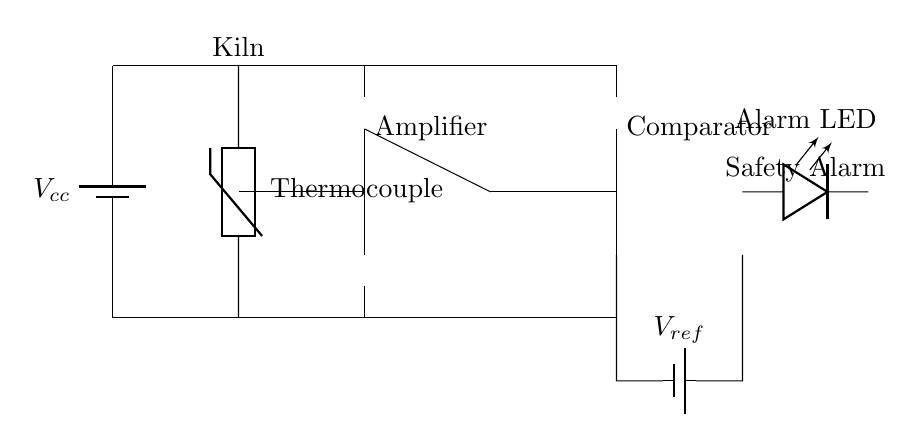What type of thermocouple is used? The circuit diagram specifies a thermistor labeled "Thermocouple," which indicates that a thermistor is employed for temperature sensing.
Answer: Thermistor What is the reference voltage labeled as? The reference voltage in the diagram is marked as "V ref," which signifies the reference point for comparison in the circuit.
Answer: V ref How many op-amps are present in the circuit? The diagram contains two op-amps, one functioning as an amplifier and the other as a comparator, which are essential for signal processing.
Answer: Two What does the alarm LED indicate? The LED labeled "Alarm LED" serves as an indicator, showing whether the circuit has triggered an alarm based on the temperature readings from the thermocouple.
Answer: Safety Alarm What is the function of the amplifier in this circuit? The amplifier boosts the low-level signal from the thermocouple, allowing it to be accurately compared by the comparator to the reference voltage. This is essential for detecting abnormal temperature levels.
Answer: To boost the signal What power supply is shown in the circuit? The circuit uses a battery marked "V cc," which supplies the necessary voltage for the entire circuit to operate, including powering the thermocouple, amplifier, comparator, and alarm LED.
Answer: Battery Why is a comparator included in this circuit? The comparator is included to compare the amplified signal from the thermocouple to the reference voltage (V ref). It determines if the temperature has exceeded a preset limit, triggering the alarm if it does.
Answer: To compare signals 